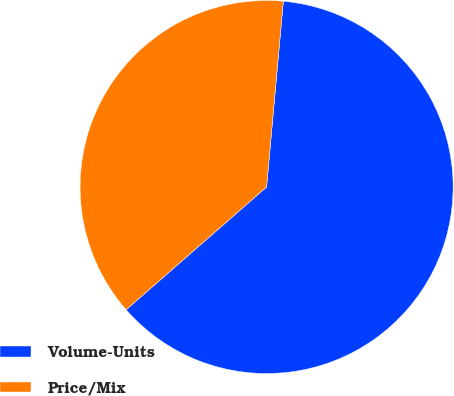Convert chart to OTSL. <chart><loc_0><loc_0><loc_500><loc_500><pie_chart><fcel>Volume-Units<fcel>Price/Mix<nl><fcel>62.14%<fcel>37.86%<nl></chart> 